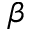Convert formula to latex. <formula><loc_0><loc_0><loc_500><loc_500>\beta</formula> 